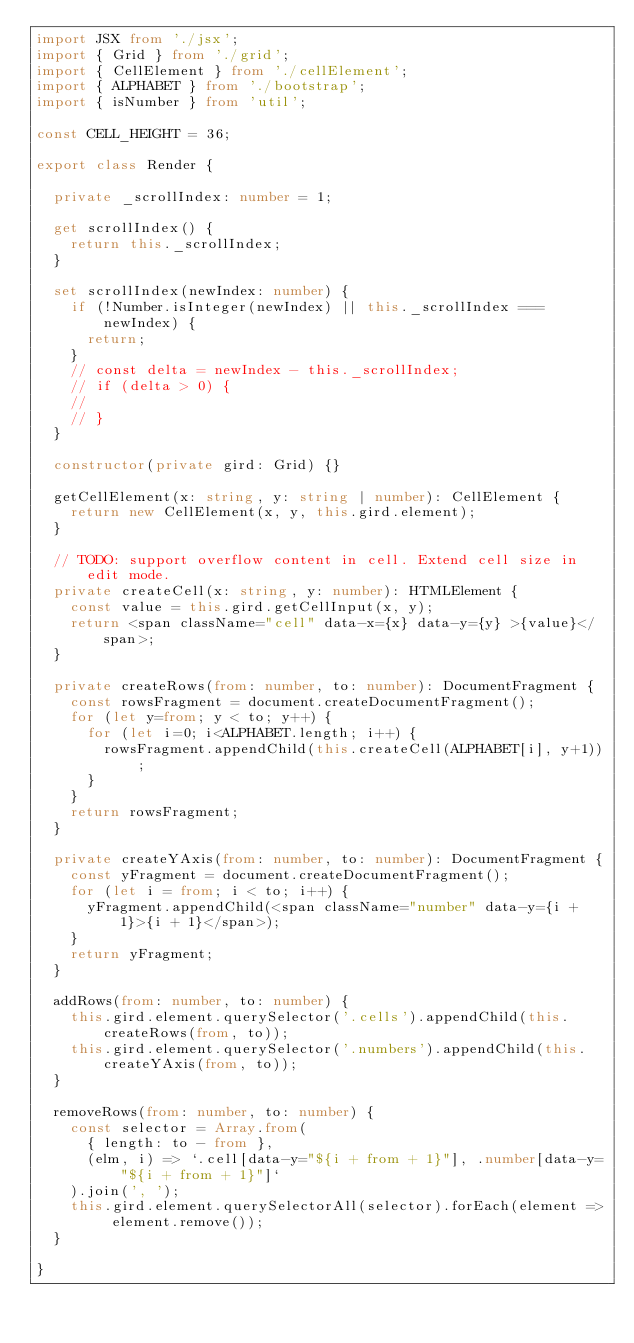Convert code to text. <code><loc_0><loc_0><loc_500><loc_500><_TypeScript_>import JSX from './jsx';
import { Grid } from './grid';
import { CellElement } from './cellElement';
import { ALPHABET } from './bootstrap';
import { isNumber } from 'util';

const CELL_HEIGHT = 36;

export class Render {

  private _scrollIndex: number = 1;

  get scrollIndex() {
    return this._scrollIndex;
  }

  set scrollIndex(newIndex: number) {
    if (!Number.isInteger(newIndex) || this._scrollIndex === newIndex) {
      return;
    }
    // const delta = newIndex - this._scrollIndex;
    // if (delta > 0) {
    //
    // }
  }

  constructor(private gird: Grid) {}

  getCellElement(x: string, y: string | number): CellElement {
    return new CellElement(x, y, this.gird.element);
  }

  // TODO: support overflow content in cell. Extend cell size in edit mode.
  private createCell(x: string, y: number): HTMLElement {
    const value = this.gird.getCellInput(x, y);
    return <span className="cell" data-x={x} data-y={y} >{value}</span>;
  }

  private createRows(from: number, to: number): DocumentFragment {
    const rowsFragment = document.createDocumentFragment();
    for (let y=from; y < to; y++) {
      for (let i=0; i<ALPHABET.length; i++) {
        rowsFragment.appendChild(this.createCell(ALPHABET[i], y+1));
      }
    }
    return rowsFragment;
  }

  private createYAxis(from: number, to: number): DocumentFragment {
    const yFragment = document.createDocumentFragment();
    for (let i = from; i < to; i++) {
      yFragment.appendChild(<span className="number" data-y={i + 1}>{i + 1}</span>);
    }
    return yFragment;
  }

  addRows(from: number, to: number) {
    this.gird.element.querySelector('.cells').appendChild(this.createRows(from, to));
    this.gird.element.querySelector('.numbers').appendChild(this.createYAxis(from, to));
  }

  removeRows(from: number, to: number) {
    const selector = Array.from(
      { length: to - from },
      (elm, i) => `.cell[data-y="${i + from + 1}"], .number[data-y="${i + from + 1}"]`
    ).join(', ');
    this.gird.element.querySelectorAll(selector).forEach(element => element.remove());
  }

}
</code> 